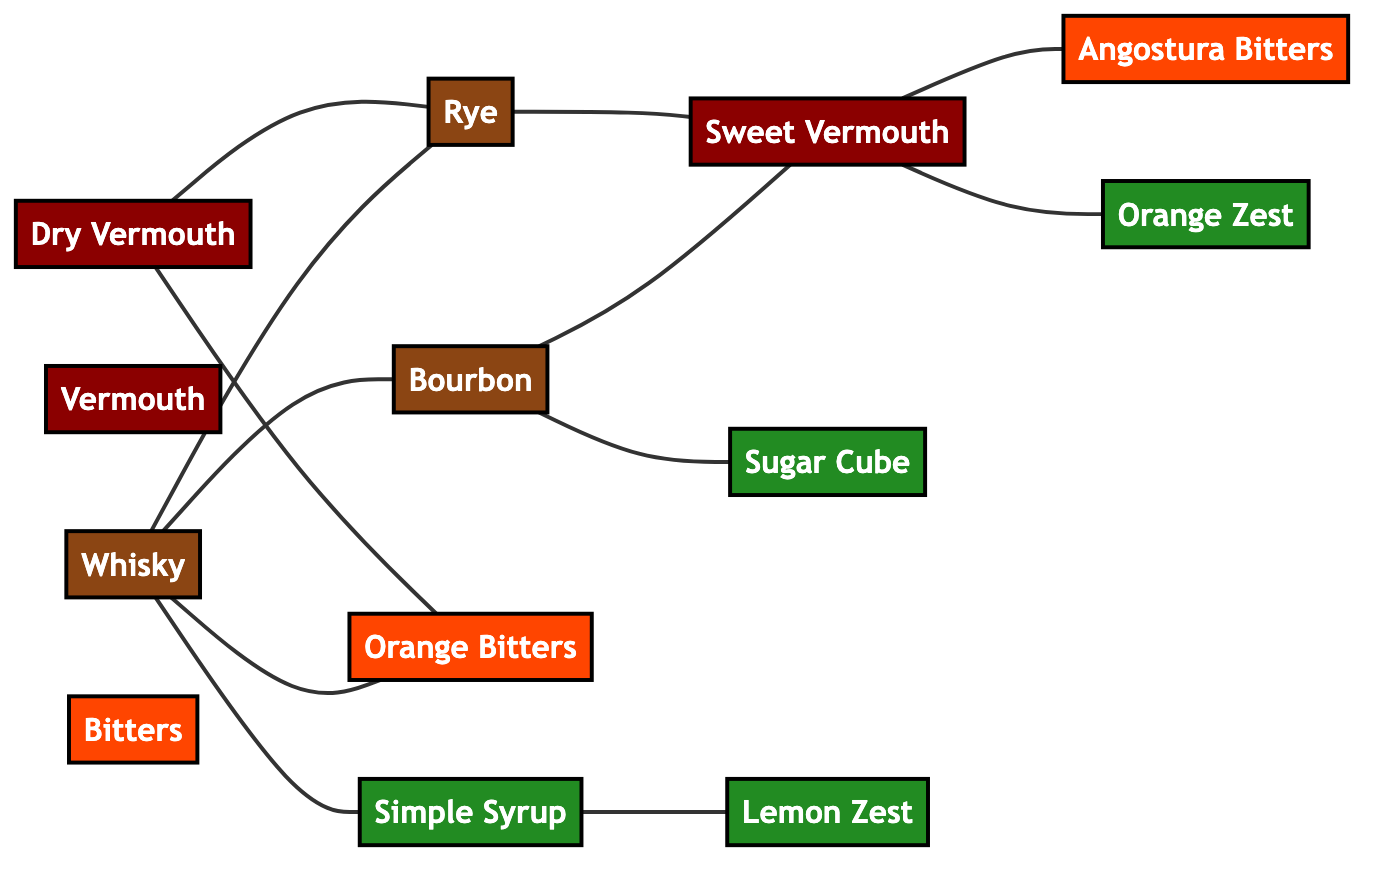What are the total number of nodes in the diagram? The diagram lists the ingredients as nodes, and counting each individual node reveals there are 13 distinct ingredients represented.
Answer: 13 Which two ingredients are directly connected to Whisky? By inspecting the edges connected to the node Whisky, we find that Bourbon and Rye are the two ingredients directly associated with it.
Answer: Bourbon, Rye How many types of vermouth are represented in the diagram? Upon examination of the nodes, there are two types of vermouth listed: Sweet Vermouth and Dry Vermouth.
Answer: 2 Which ingredient is connected to Sweet Vermouth? Looking at the edges originating from the Sweet Vermouth node, it connects to Angostura Bitters and has links to both Bourbon and Rye. Therefore, Sweet Vermouth is directly linked with Angostura Bitters specifically.
Answer: Angostura Bitters What is the relationship between Dry Vermouth and Rye? The diagram shows a direct edge connecting Dry Vermouth to Rye, indicating a direct relationship between these two ingredients.
Answer: Direct connection How many different types of bitters are present in the graph? By analyzing the nodes, there are two distinct types of bitters represented: Angostura Bitters and Orange Bitters.
Answer: 2 What ingredient does Simple Syrup directly connect with in the graph? The edges indicate that Simple Syrup is directly connected to Lemon Zest, showing a direct relationship between these two components.
Answer: Lemon Zest If we consider all edges, which ingredient has the most direct connections? A careful count of the connections for each node shows that Whisky is directly connected to five other ingredients, making it the most connected element in the diagram.
Answer: Whisky Which ingredients are associated with Sweet Vermouth? Sweet Vermouth has direct links to Bourbon, Rye, Angostura Bitters, and Orange Zest, indicating multiple associations. Hence, it is tied to those four ingredients.
Answer: Bourbon, Rye, Angostura Bitters, Orange Zest 